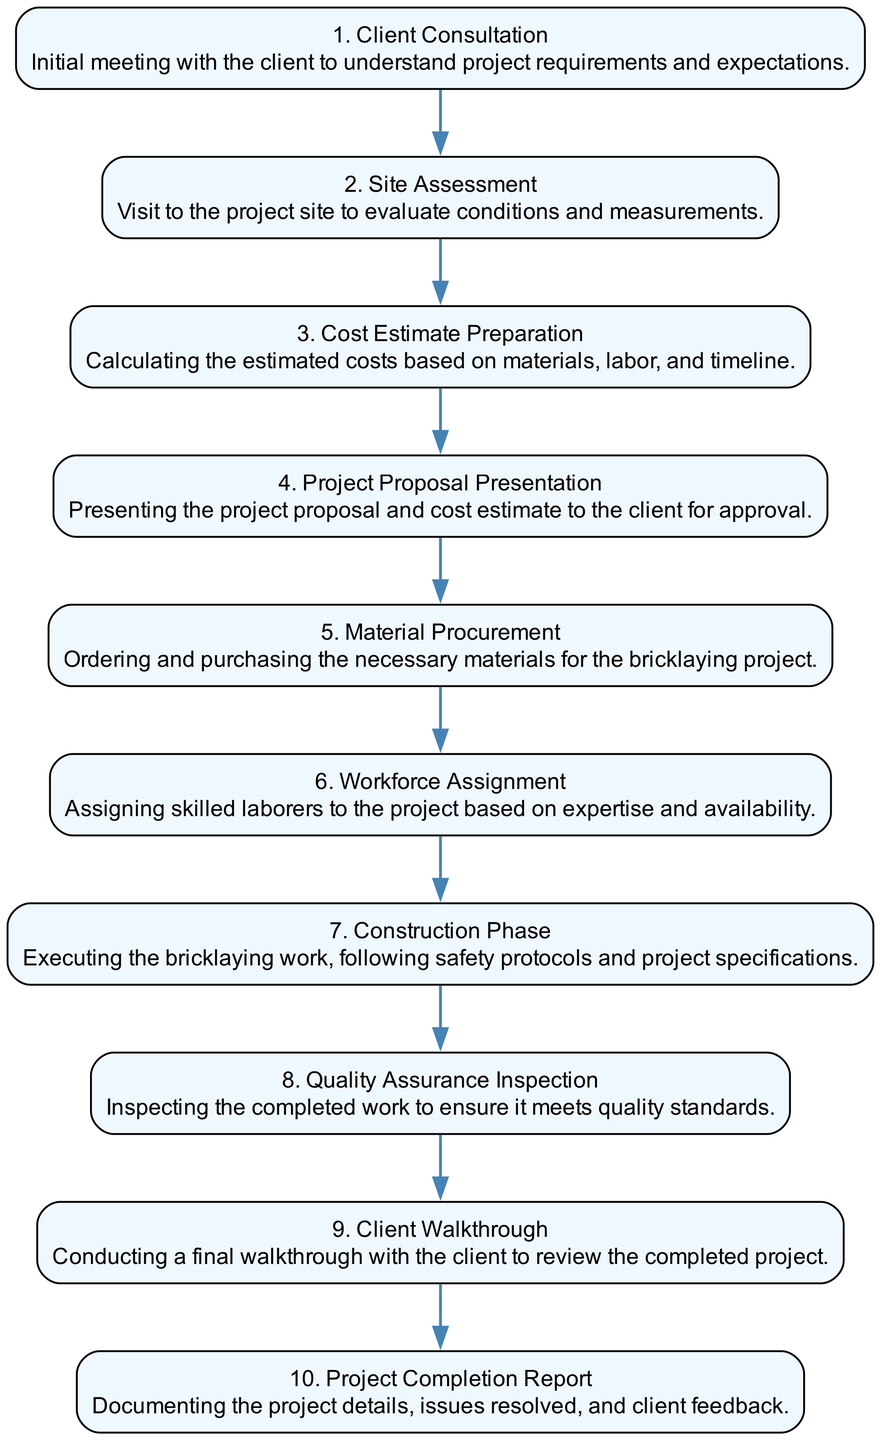What is the first step in the workflow? The first step is "Client Consultation," which is noted as step 1 in the diagram. This is where the initial meeting with the client takes place to understand project requirements and expectations.
Answer: Client Consultation What follows after Material Procurement? The step after "Material Procurement" is "Workforce Assignment," which is step 6. This shows the sequence of the workflow where the next action is to assign skilled laborers to the project.
Answer: Workforce Assignment How many steps are in the workflow? There are a total of 10 steps in the workflow, each representing a phase in the bricklaying project from start to completion.
Answer: 10 What is the final step depicted in the diagram? The final step is "Project Completion Report," listed as step 10. This step involves documenting the project details, issues resolved, and client feedback upon completion.
Answer: Project Completion Report Which step comes before the Quality Assurance Inspection? The step that precedes "Quality Assurance Inspection" is the "Construction Phase," which is step 7. This indicates the direct flow of work, showing what must be completed before quality checks are done.
Answer: Construction Phase How are the steps connected? The steps are connected in a linear fashion, where each step points to the next in sequence without any branching. This indicates a straightforward progression from start to finish.
Answer: Linear connection What is assessed during the Site Assessment step? During the "Site Assessment" step, conditions and measurements of the project site are evaluated. This is the main purpose of this stage, noted for ensuring that the project can be effectively planned.
Answer: Conditions and measurements Which step involves the presentation of the project proposal? The step that involves the presentation of the project proposal is "Project Proposal Presentation," which is step 4 in the diagram. This is where the proposal and cost estimate are presented to the client for approval.
Answer: Project Proposal Presentation What aspect does the Client Walkthrough address? The "Client Walkthrough" addresses the review of the completed project with the client to ensure satisfaction before finalizing the project. It is step 9 in the workflow.
Answer: Review of completed project 